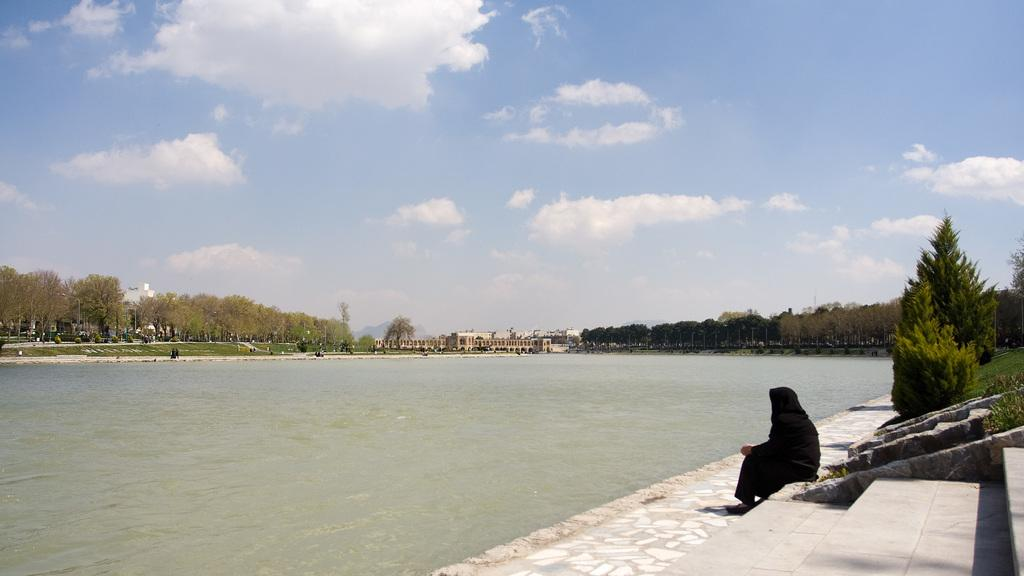What is the primary element in the image? There is water in the image. What is the person in the image doing? The person is sitting on a platform in the image. What type of vegetation is present in the image? There is grass and plants in the image. What can be seen in the background of the image? There are trees, buildings, and the sky visible in the background of the image. What is the condition of the sky in the image? The sky is visible in the background of the image, and there are clouds present. What type of lace is being used to decorate the art in the image? There is no art or lace present in the image; it features a person sitting on a platform near water, surrounded by vegetation and buildings. 